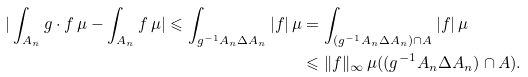<formula> <loc_0><loc_0><loc_500><loc_500>| \int _ { A _ { n } } g \cdot f \, \mu - \int _ { A _ { n } } f \, \mu | \leqslant \int _ { g ^ { - 1 } A _ { n } \Delta A _ { n } } | f | \, \mu & = \int _ { ( g ^ { - 1 } A _ { n } \Delta A _ { n } ) \cap A } | f | \, \mu \\ & \leqslant \| f \| _ { \infty } \, \mu ( ( g ^ { - 1 } A _ { n } \Delta A _ { n } ) \cap A ) .</formula> 